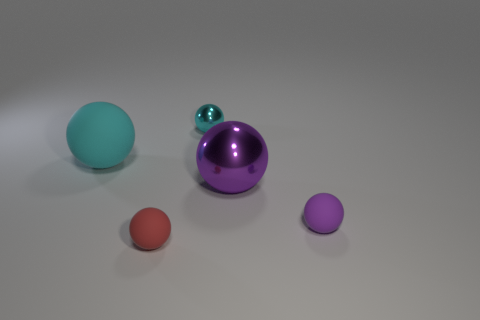How many tiny brown matte cylinders are there?
Offer a terse response. 0. Are there fewer red objects behind the big cyan sphere than red rubber things behind the red object?
Keep it short and to the point. No. Are there fewer large purple shiny spheres that are left of the large matte sphere than small green metallic spheres?
Make the answer very short. No. There is a ball that is to the left of the matte sphere that is in front of the rubber object that is right of the red ball; what is it made of?
Provide a succinct answer. Rubber. How many things are balls behind the tiny purple thing or objects that are on the right side of the large purple shiny sphere?
Your answer should be very brief. 4. There is a small cyan object that is the same shape as the large rubber object; what is it made of?
Your response must be concise. Metal. How many matte things are either cyan things or big cyan spheres?
Keep it short and to the point. 1. What shape is the red object that is the same material as the big cyan thing?
Provide a succinct answer. Sphere. What number of small red rubber things have the same shape as the large purple object?
Give a very brief answer. 1. Does the small object on the right side of the tiny cyan metallic object have the same shape as the cyan thing to the left of the small shiny object?
Offer a terse response. Yes. 